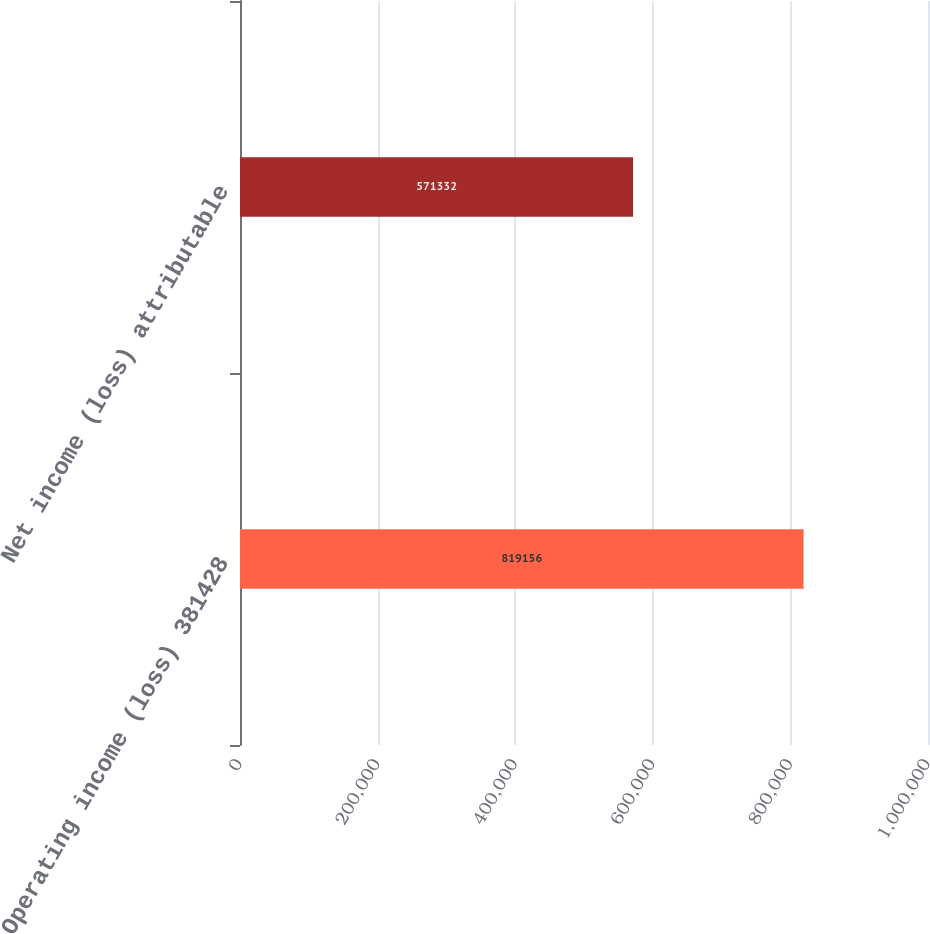<chart> <loc_0><loc_0><loc_500><loc_500><bar_chart><fcel>Operating income (loss) 381428<fcel>Net income (loss) attributable<nl><fcel>819156<fcel>571332<nl></chart> 